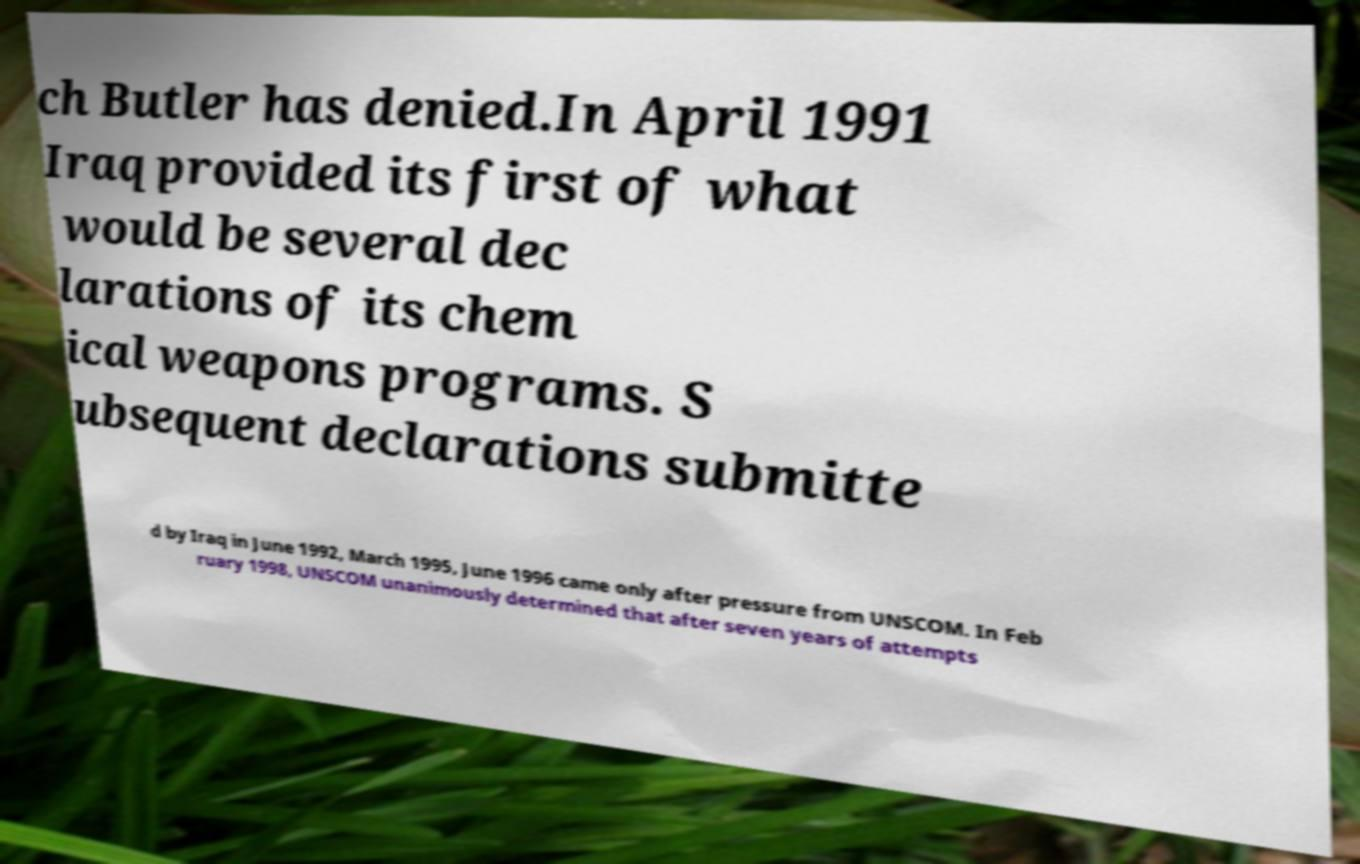Can you accurately transcribe the text from the provided image for me? ch Butler has denied.In April 1991 Iraq provided its first of what would be several dec larations of its chem ical weapons programs. S ubsequent declarations submitte d by Iraq in June 1992, March 1995, June 1996 came only after pressure from UNSCOM. In Feb ruary 1998, UNSCOM unanimously determined that after seven years of attempts 